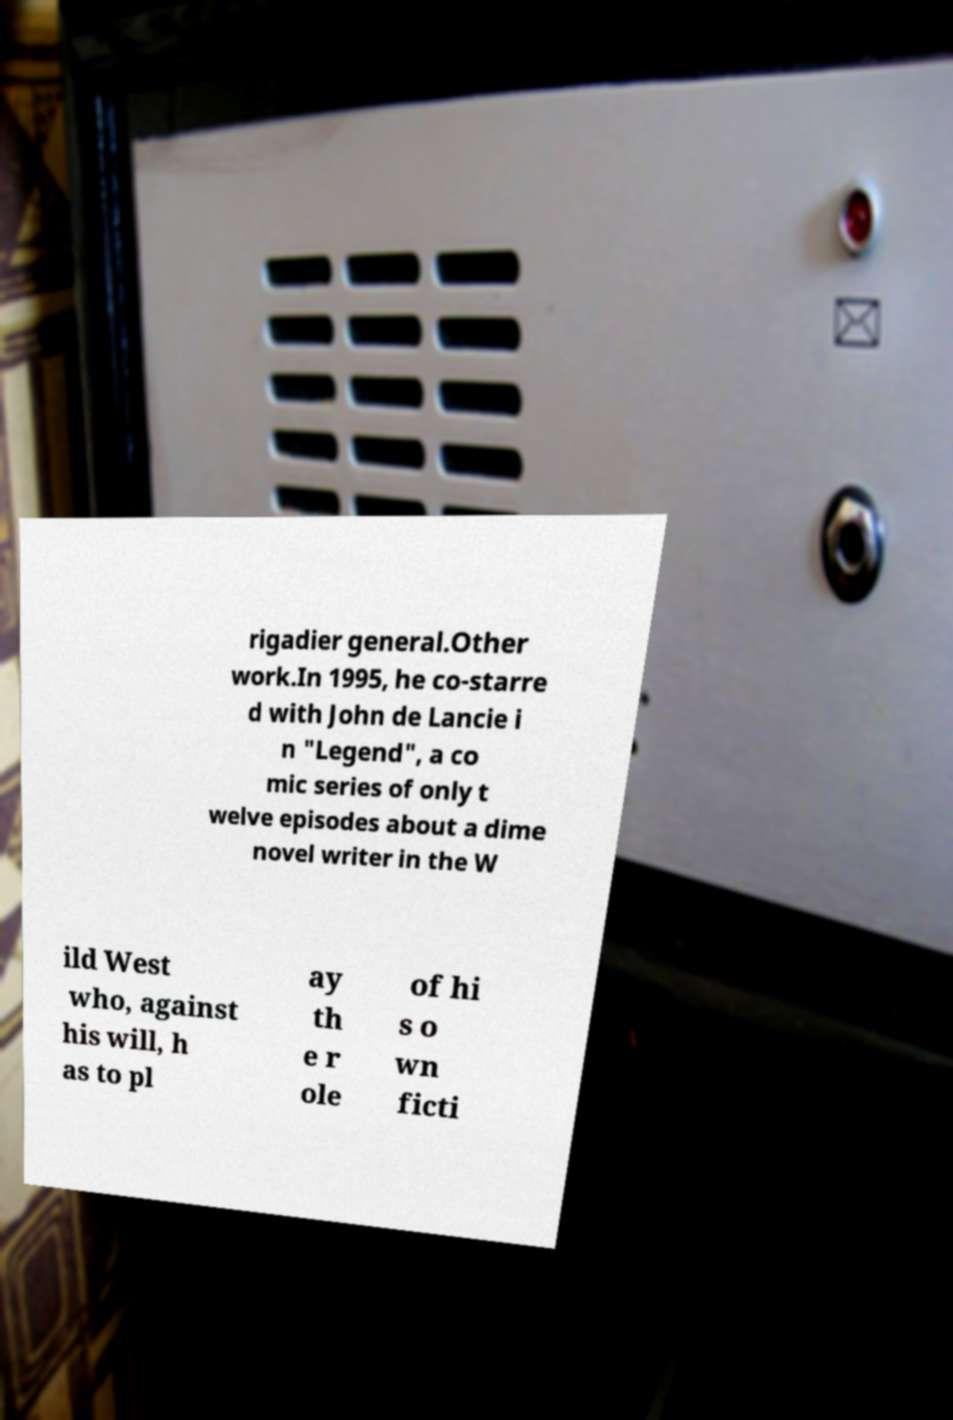Can you read and provide the text displayed in the image?This photo seems to have some interesting text. Can you extract and type it out for me? rigadier general.Other work.In 1995, he co-starre d with John de Lancie i n "Legend", a co mic series of only t welve episodes about a dime novel writer in the W ild West who, against his will, h as to pl ay th e r ole of hi s o wn ficti 